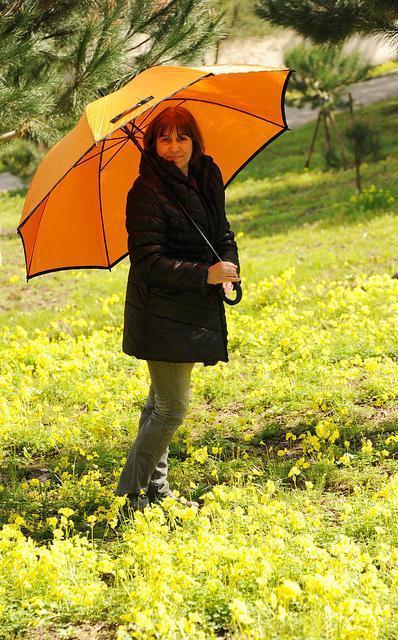How many people are visible?
Give a very brief answer. 1. How many red bird in this image?
Give a very brief answer. 0. 